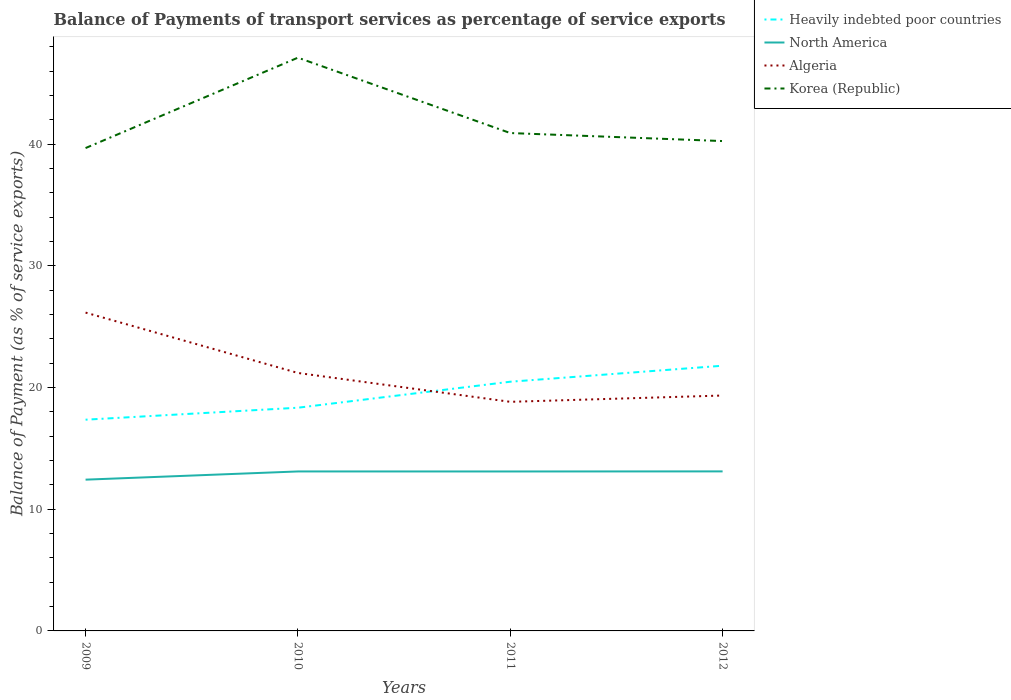How many different coloured lines are there?
Ensure brevity in your answer.  4. Does the line corresponding to Algeria intersect with the line corresponding to Korea (Republic)?
Ensure brevity in your answer.  No. Across all years, what is the maximum balance of payments of transport services in Heavily indebted poor countries?
Offer a terse response. 17.36. What is the total balance of payments of transport services in Korea (Republic) in the graph?
Make the answer very short. -7.43. What is the difference between the highest and the second highest balance of payments of transport services in Algeria?
Ensure brevity in your answer.  7.33. Is the balance of payments of transport services in Korea (Republic) strictly greater than the balance of payments of transport services in Heavily indebted poor countries over the years?
Offer a very short reply. No. How many lines are there?
Ensure brevity in your answer.  4. How many years are there in the graph?
Offer a terse response. 4. Are the values on the major ticks of Y-axis written in scientific E-notation?
Give a very brief answer. No. How are the legend labels stacked?
Your answer should be very brief. Vertical. What is the title of the graph?
Offer a very short reply. Balance of Payments of transport services as percentage of service exports. What is the label or title of the Y-axis?
Your answer should be very brief. Balance of Payment (as % of service exports). What is the Balance of Payment (as % of service exports) of Heavily indebted poor countries in 2009?
Your answer should be very brief. 17.36. What is the Balance of Payment (as % of service exports) of North America in 2009?
Provide a succinct answer. 12.43. What is the Balance of Payment (as % of service exports) in Algeria in 2009?
Make the answer very short. 26.15. What is the Balance of Payment (as % of service exports) in Korea (Republic) in 2009?
Your answer should be compact. 39.67. What is the Balance of Payment (as % of service exports) of Heavily indebted poor countries in 2010?
Offer a terse response. 18.34. What is the Balance of Payment (as % of service exports) of North America in 2010?
Your response must be concise. 13.1. What is the Balance of Payment (as % of service exports) in Algeria in 2010?
Provide a succinct answer. 21.2. What is the Balance of Payment (as % of service exports) in Korea (Republic) in 2010?
Make the answer very short. 47.1. What is the Balance of Payment (as % of service exports) of Heavily indebted poor countries in 2011?
Your response must be concise. 20.48. What is the Balance of Payment (as % of service exports) of North America in 2011?
Offer a very short reply. 13.1. What is the Balance of Payment (as % of service exports) of Algeria in 2011?
Your response must be concise. 18.82. What is the Balance of Payment (as % of service exports) in Korea (Republic) in 2011?
Offer a very short reply. 40.91. What is the Balance of Payment (as % of service exports) of Heavily indebted poor countries in 2012?
Give a very brief answer. 21.79. What is the Balance of Payment (as % of service exports) in North America in 2012?
Your response must be concise. 13.11. What is the Balance of Payment (as % of service exports) in Algeria in 2012?
Offer a very short reply. 19.34. What is the Balance of Payment (as % of service exports) in Korea (Republic) in 2012?
Your answer should be compact. 40.25. Across all years, what is the maximum Balance of Payment (as % of service exports) of Heavily indebted poor countries?
Your answer should be compact. 21.79. Across all years, what is the maximum Balance of Payment (as % of service exports) in North America?
Provide a succinct answer. 13.11. Across all years, what is the maximum Balance of Payment (as % of service exports) in Algeria?
Keep it short and to the point. 26.15. Across all years, what is the maximum Balance of Payment (as % of service exports) in Korea (Republic)?
Make the answer very short. 47.1. Across all years, what is the minimum Balance of Payment (as % of service exports) of Heavily indebted poor countries?
Offer a very short reply. 17.36. Across all years, what is the minimum Balance of Payment (as % of service exports) in North America?
Your response must be concise. 12.43. Across all years, what is the minimum Balance of Payment (as % of service exports) of Algeria?
Your response must be concise. 18.82. Across all years, what is the minimum Balance of Payment (as % of service exports) in Korea (Republic)?
Give a very brief answer. 39.67. What is the total Balance of Payment (as % of service exports) in Heavily indebted poor countries in the graph?
Your response must be concise. 77.96. What is the total Balance of Payment (as % of service exports) in North America in the graph?
Your response must be concise. 51.74. What is the total Balance of Payment (as % of service exports) of Algeria in the graph?
Offer a very short reply. 85.51. What is the total Balance of Payment (as % of service exports) of Korea (Republic) in the graph?
Provide a short and direct response. 167.93. What is the difference between the Balance of Payment (as % of service exports) in Heavily indebted poor countries in 2009 and that in 2010?
Provide a short and direct response. -0.98. What is the difference between the Balance of Payment (as % of service exports) of North America in 2009 and that in 2010?
Make the answer very short. -0.67. What is the difference between the Balance of Payment (as % of service exports) of Algeria in 2009 and that in 2010?
Give a very brief answer. 4.96. What is the difference between the Balance of Payment (as % of service exports) in Korea (Republic) in 2009 and that in 2010?
Make the answer very short. -7.43. What is the difference between the Balance of Payment (as % of service exports) of Heavily indebted poor countries in 2009 and that in 2011?
Provide a succinct answer. -3.12. What is the difference between the Balance of Payment (as % of service exports) in North America in 2009 and that in 2011?
Your answer should be very brief. -0.67. What is the difference between the Balance of Payment (as % of service exports) in Algeria in 2009 and that in 2011?
Offer a very short reply. 7.33. What is the difference between the Balance of Payment (as % of service exports) of Korea (Republic) in 2009 and that in 2011?
Offer a very short reply. -1.23. What is the difference between the Balance of Payment (as % of service exports) in Heavily indebted poor countries in 2009 and that in 2012?
Provide a short and direct response. -4.43. What is the difference between the Balance of Payment (as % of service exports) of North America in 2009 and that in 2012?
Your answer should be compact. -0.68. What is the difference between the Balance of Payment (as % of service exports) in Algeria in 2009 and that in 2012?
Keep it short and to the point. 6.81. What is the difference between the Balance of Payment (as % of service exports) in Korea (Republic) in 2009 and that in 2012?
Offer a very short reply. -0.57. What is the difference between the Balance of Payment (as % of service exports) in Heavily indebted poor countries in 2010 and that in 2011?
Keep it short and to the point. -2.14. What is the difference between the Balance of Payment (as % of service exports) of North America in 2010 and that in 2011?
Offer a very short reply. 0. What is the difference between the Balance of Payment (as % of service exports) in Algeria in 2010 and that in 2011?
Your answer should be compact. 2.37. What is the difference between the Balance of Payment (as % of service exports) of Korea (Republic) in 2010 and that in 2011?
Make the answer very short. 6.19. What is the difference between the Balance of Payment (as % of service exports) in Heavily indebted poor countries in 2010 and that in 2012?
Make the answer very short. -3.45. What is the difference between the Balance of Payment (as % of service exports) of North America in 2010 and that in 2012?
Provide a succinct answer. -0. What is the difference between the Balance of Payment (as % of service exports) in Algeria in 2010 and that in 2012?
Offer a very short reply. 1.85. What is the difference between the Balance of Payment (as % of service exports) of Korea (Republic) in 2010 and that in 2012?
Your response must be concise. 6.85. What is the difference between the Balance of Payment (as % of service exports) in Heavily indebted poor countries in 2011 and that in 2012?
Make the answer very short. -1.31. What is the difference between the Balance of Payment (as % of service exports) of North America in 2011 and that in 2012?
Your response must be concise. -0.01. What is the difference between the Balance of Payment (as % of service exports) in Algeria in 2011 and that in 2012?
Make the answer very short. -0.52. What is the difference between the Balance of Payment (as % of service exports) in Korea (Republic) in 2011 and that in 2012?
Ensure brevity in your answer.  0.66. What is the difference between the Balance of Payment (as % of service exports) of Heavily indebted poor countries in 2009 and the Balance of Payment (as % of service exports) of North America in 2010?
Give a very brief answer. 4.25. What is the difference between the Balance of Payment (as % of service exports) in Heavily indebted poor countries in 2009 and the Balance of Payment (as % of service exports) in Algeria in 2010?
Make the answer very short. -3.84. What is the difference between the Balance of Payment (as % of service exports) of Heavily indebted poor countries in 2009 and the Balance of Payment (as % of service exports) of Korea (Republic) in 2010?
Give a very brief answer. -29.75. What is the difference between the Balance of Payment (as % of service exports) in North America in 2009 and the Balance of Payment (as % of service exports) in Algeria in 2010?
Keep it short and to the point. -8.77. What is the difference between the Balance of Payment (as % of service exports) of North America in 2009 and the Balance of Payment (as % of service exports) of Korea (Republic) in 2010?
Provide a short and direct response. -34.67. What is the difference between the Balance of Payment (as % of service exports) in Algeria in 2009 and the Balance of Payment (as % of service exports) in Korea (Republic) in 2010?
Your answer should be compact. -20.95. What is the difference between the Balance of Payment (as % of service exports) of Heavily indebted poor countries in 2009 and the Balance of Payment (as % of service exports) of North America in 2011?
Keep it short and to the point. 4.25. What is the difference between the Balance of Payment (as % of service exports) of Heavily indebted poor countries in 2009 and the Balance of Payment (as % of service exports) of Algeria in 2011?
Make the answer very short. -1.47. What is the difference between the Balance of Payment (as % of service exports) of Heavily indebted poor countries in 2009 and the Balance of Payment (as % of service exports) of Korea (Republic) in 2011?
Offer a terse response. -23.55. What is the difference between the Balance of Payment (as % of service exports) in North America in 2009 and the Balance of Payment (as % of service exports) in Algeria in 2011?
Offer a very short reply. -6.39. What is the difference between the Balance of Payment (as % of service exports) of North America in 2009 and the Balance of Payment (as % of service exports) of Korea (Republic) in 2011?
Your response must be concise. -28.48. What is the difference between the Balance of Payment (as % of service exports) of Algeria in 2009 and the Balance of Payment (as % of service exports) of Korea (Republic) in 2011?
Give a very brief answer. -14.75. What is the difference between the Balance of Payment (as % of service exports) in Heavily indebted poor countries in 2009 and the Balance of Payment (as % of service exports) in North America in 2012?
Provide a short and direct response. 4.25. What is the difference between the Balance of Payment (as % of service exports) in Heavily indebted poor countries in 2009 and the Balance of Payment (as % of service exports) in Algeria in 2012?
Offer a very short reply. -1.99. What is the difference between the Balance of Payment (as % of service exports) in Heavily indebted poor countries in 2009 and the Balance of Payment (as % of service exports) in Korea (Republic) in 2012?
Give a very brief answer. -22.89. What is the difference between the Balance of Payment (as % of service exports) in North America in 2009 and the Balance of Payment (as % of service exports) in Algeria in 2012?
Your answer should be compact. -6.91. What is the difference between the Balance of Payment (as % of service exports) in North America in 2009 and the Balance of Payment (as % of service exports) in Korea (Republic) in 2012?
Offer a terse response. -27.82. What is the difference between the Balance of Payment (as % of service exports) of Algeria in 2009 and the Balance of Payment (as % of service exports) of Korea (Republic) in 2012?
Provide a succinct answer. -14.09. What is the difference between the Balance of Payment (as % of service exports) of Heavily indebted poor countries in 2010 and the Balance of Payment (as % of service exports) of North America in 2011?
Provide a short and direct response. 5.24. What is the difference between the Balance of Payment (as % of service exports) in Heavily indebted poor countries in 2010 and the Balance of Payment (as % of service exports) in Algeria in 2011?
Your answer should be compact. -0.48. What is the difference between the Balance of Payment (as % of service exports) of Heavily indebted poor countries in 2010 and the Balance of Payment (as % of service exports) of Korea (Republic) in 2011?
Ensure brevity in your answer.  -22.57. What is the difference between the Balance of Payment (as % of service exports) of North America in 2010 and the Balance of Payment (as % of service exports) of Algeria in 2011?
Your answer should be compact. -5.72. What is the difference between the Balance of Payment (as % of service exports) of North America in 2010 and the Balance of Payment (as % of service exports) of Korea (Republic) in 2011?
Give a very brief answer. -27.8. What is the difference between the Balance of Payment (as % of service exports) of Algeria in 2010 and the Balance of Payment (as % of service exports) of Korea (Republic) in 2011?
Provide a succinct answer. -19.71. What is the difference between the Balance of Payment (as % of service exports) in Heavily indebted poor countries in 2010 and the Balance of Payment (as % of service exports) in North America in 2012?
Ensure brevity in your answer.  5.23. What is the difference between the Balance of Payment (as % of service exports) of Heavily indebted poor countries in 2010 and the Balance of Payment (as % of service exports) of Algeria in 2012?
Ensure brevity in your answer.  -1. What is the difference between the Balance of Payment (as % of service exports) of Heavily indebted poor countries in 2010 and the Balance of Payment (as % of service exports) of Korea (Republic) in 2012?
Your answer should be very brief. -21.91. What is the difference between the Balance of Payment (as % of service exports) of North America in 2010 and the Balance of Payment (as % of service exports) of Algeria in 2012?
Provide a short and direct response. -6.24. What is the difference between the Balance of Payment (as % of service exports) in North America in 2010 and the Balance of Payment (as % of service exports) in Korea (Republic) in 2012?
Your answer should be very brief. -27.14. What is the difference between the Balance of Payment (as % of service exports) of Algeria in 2010 and the Balance of Payment (as % of service exports) of Korea (Republic) in 2012?
Give a very brief answer. -19.05. What is the difference between the Balance of Payment (as % of service exports) of Heavily indebted poor countries in 2011 and the Balance of Payment (as % of service exports) of North America in 2012?
Your answer should be very brief. 7.37. What is the difference between the Balance of Payment (as % of service exports) of Heavily indebted poor countries in 2011 and the Balance of Payment (as % of service exports) of Algeria in 2012?
Keep it short and to the point. 1.13. What is the difference between the Balance of Payment (as % of service exports) in Heavily indebted poor countries in 2011 and the Balance of Payment (as % of service exports) in Korea (Republic) in 2012?
Give a very brief answer. -19.77. What is the difference between the Balance of Payment (as % of service exports) in North America in 2011 and the Balance of Payment (as % of service exports) in Algeria in 2012?
Your answer should be compact. -6.24. What is the difference between the Balance of Payment (as % of service exports) of North America in 2011 and the Balance of Payment (as % of service exports) of Korea (Republic) in 2012?
Make the answer very short. -27.15. What is the difference between the Balance of Payment (as % of service exports) of Algeria in 2011 and the Balance of Payment (as % of service exports) of Korea (Republic) in 2012?
Give a very brief answer. -21.42. What is the average Balance of Payment (as % of service exports) in Heavily indebted poor countries per year?
Give a very brief answer. 19.49. What is the average Balance of Payment (as % of service exports) of North America per year?
Provide a short and direct response. 12.94. What is the average Balance of Payment (as % of service exports) of Algeria per year?
Give a very brief answer. 21.38. What is the average Balance of Payment (as % of service exports) in Korea (Republic) per year?
Provide a short and direct response. 41.98. In the year 2009, what is the difference between the Balance of Payment (as % of service exports) of Heavily indebted poor countries and Balance of Payment (as % of service exports) of North America?
Give a very brief answer. 4.93. In the year 2009, what is the difference between the Balance of Payment (as % of service exports) of Heavily indebted poor countries and Balance of Payment (as % of service exports) of Algeria?
Keep it short and to the point. -8.8. In the year 2009, what is the difference between the Balance of Payment (as % of service exports) of Heavily indebted poor countries and Balance of Payment (as % of service exports) of Korea (Republic)?
Provide a succinct answer. -22.32. In the year 2009, what is the difference between the Balance of Payment (as % of service exports) of North America and Balance of Payment (as % of service exports) of Algeria?
Provide a succinct answer. -13.73. In the year 2009, what is the difference between the Balance of Payment (as % of service exports) of North America and Balance of Payment (as % of service exports) of Korea (Republic)?
Provide a succinct answer. -27.24. In the year 2009, what is the difference between the Balance of Payment (as % of service exports) of Algeria and Balance of Payment (as % of service exports) of Korea (Republic)?
Offer a very short reply. -13.52. In the year 2010, what is the difference between the Balance of Payment (as % of service exports) in Heavily indebted poor countries and Balance of Payment (as % of service exports) in North America?
Your response must be concise. 5.24. In the year 2010, what is the difference between the Balance of Payment (as % of service exports) in Heavily indebted poor countries and Balance of Payment (as % of service exports) in Algeria?
Your answer should be compact. -2.86. In the year 2010, what is the difference between the Balance of Payment (as % of service exports) in Heavily indebted poor countries and Balance of Payment (as % of service exports) in Korea (Republic)?
Your response must be concise. -28.76. In the year 2010, what is the difference between the Balance of Payment (as % of service exports) in North America and Balance of Payment (as % of service exports) in Algeria?
Provide a succinct answer. -8.09. In the year 2010, what is the difference between the Balance of Payment (as % of service exports) in North America and Balance of Payment (as % of service exports) in Korea (Republic)?
Your answer should be very brief. -34. In the year 2010, what is the difference between the Balance of Payment (as % of service exports) in Algeria and Balance of Payment (as % of service exports) in Korea (Republic)?
Keep it short and to the point. -25.91. In the year 2011, what is the difference between the Balance of Payment (as % of service exports) of Heavily indebted poor countries and Balance of Payment (as % of service exports) of North America?
Give a very brief answer. 7.37. In the year 2011, what is the difference between the Balance of Payment (as % of service exports) of Heavily indebted poor countries and Balance of Payment (as % of service exports) of Algeria?
Your answer should be compact. 1.65. In the year 2011, what is the difference between the Balance of Payment (as % of service exports) in Heavily indebted poor countries and Balance of Payment (as % of service exports) in Korea (Republic)?
Give a very brief answer. -20.43. In the year 2011, what is the difference between the Balance of Payment (as % of service exports) of North America and Balance of Payment (as % of service exports) of Algeria?
Your response must be concise. -5.72. In the year 2011, what is the difference between the Balance of Payment (as % of service exports) of North America and Balance of Payment (as % of service exports) of Korea (Republic)?
Ensure brevity in your answer.  -27.81. In the year 2011, what is the difference between the Balance of Payment (as % of service exports) in Algeria and Balance of Payment (as % of service exports) in Korea (Republic)?
Your answer should be compact. -22.08. In the year 2012, what is the difference between the Balance of Payment (as % of service exports) in Heavily indebted poor countries and Balance of Payment (as % of service exports) in North America?
Ensure brevity in your answer.  8.68. In the year 2012, what is the difference between the Balance of Payment (as % of service exports) of Heavily indebted poor countries and Balance of Payment (as % of service exports) of Algeria?
Make the answer very short. 2.45. In the year 2012, what is the difference between the Balance of Payment (as % of service exports) of Heavily indebted poor countries and Balance of Payment (as % of service exports) of Korea (Republic)?
Keep it short and to the point. -18.46. In the year 2012, what is the difference between the Balance of Payment (as % of service exports) in North America and Balance of Payment (as % of service exports) in Algeria?
Give a very brief answer. -6.23. In the year 2012, what is the difference between the Balance of Payment (as % of service exports) of North America and Balance of Payment (as % of service exports) of Korea (Republic)?
Keep it short and to the point. -27.14. In the year 2012, what is the difference between the Balance of Payment (as % of service exports) in Algeria and Balance of Payment (as % of service exports) in Korea (Republic)?
Ensure brevity in your answer.  -20.91. What is the ratio of the Balance of Payment (as % of service exports) in Heavily indebted poor countries in 2009 to that in 2010?
Your answer should be compact. 0.95. What is the ratio of the Balance of Payment (as % of service exports) of North America in 2009 to that in 2010?
Your answer should be compact. 0.95. What is the ratio of the Balance of Payment (as % of service exports) in Algeria in 2009 to that in 2010?
Offer a very short reply. 1.23. What is the ratio of the Balance of Payment (as % of service exports) in Korea (Republic) in 2009 to that in 2010?
Keep it short and to the point. 0.84. What is the ratio of the Balance of Payment (as % of service exports) of Heavily indebted poor countries in 2009 to that in 2011?
Your response must be concise. 0.85. What is the ratio of the Balance of Payment (as % of service exports) of North America in 2009 to that in 2011?
Your response must be concise. 0.95. What is the ratio of the Balance of Payment (as % of service exports) in Algeria in 2009 to that in 2011?
Give a very brief answer. 1.39. What is the ratio of the Balance of Payment (as % of service exports) of Korea (Republic) in 2009 to that in 2011?
Provide a succinct answer. 0.97. What is the ratio of the Balance of Payment (as % of service exports) of Heavily indebted poor countries in 2009 to that in 2012?
Keep it short and to the point. 0.8. What is the ratio of the Balance of Payment (as % of service exports) in North America in 2009 to that in 2012?
Provide a succinct answer. 0.95. What is the ratio of the Balance of Payment (as % of service exports) of Algeria in 2009 to that in 2012?
Offer a very short reply. 1.35. What is the ratio of the Balance of Payment (as % of service exports) in Korea (Republic) in 2009 to that in 2012?
Your answer should be compact. 0.99. What is the ratio of the Balance of Payment (as % of service exports) of Heavily indebted poor countries in 2010 to that in 2011?
Ensure brevity in your answer.  0.9. What is the ratio of the Balance of Payment (as % of service exports) in North America in 2010 to that in 2011?
Provide a short and direct response. 1. What is the ratio of the Balance of Payment (as % of service exports) in Algeria in 2010 to that in 2011?
Your answer should be compact. 1.13. What is the ratio of the Balance of Payment (as % of service exports) of Korea (Republic) in 2010 to that in 2011?
Offer a very short reply. 1.15. What is the ratio of the Balance of Payment (as % of service exports) of Heavily indebted poor countries in 2010 to that in 2012?
Offer a very short reply. 0.84. What is the ratio of the Balance of Payment (as % of service exports) of North America in 2010 to that in 2012?
Provide a short and direct response. 1. What is the ratio of the Balance of Payment (as % of service exports) in Algeria in 2010 to that in 2012?
Offer a terse response. 1.1. What is the ratio of the Balance of Payment (as % of service exports) in Korea (Republic) in 2010 to that in 2012?
Keep it short and to the point. 1.17. What is the ratio of the Balance of Payment (as % of service exports) of Heavily indebted poor countries in 2011 to that in 2012?
Your answer should be compact. 0.94. What is the ratio of the Balance of Payment (as % of service exports) in North America in 2011 to that in 2012?
Your answer should be very brief. 1. What is the ratio of the Balance of Payment (as % of service exports) in Algeria in 2011 to that in 2012?
Keep it short and to the point. 0.97. What is the ratio of the Balance of Payment (as % of service exports) of Korea (Republic) in 2011 to that in 2012?
Give a very brief answer. 1.02. What is the difference between the highest and the second highest Balance of Payment (as % of service exports) in Heavily indebted poor countries?
Ensure brevity in your answer.  1.31. What is the difference between the highest and the second highest Balance of Payment (as % of service exports) in North America?
Your answer should be very brief. 0. What is the difference between the highest and the second highest Balance of Payment (as % of service exports) in Algeria?
Provide a short and direct response. 4.96. What is the difference between the highest and the second highest Balance of Payment (as % of service exports) in Korea (Republic)?
Offer a terse response. 6.19. What is the difference between the highest and the lowest Balance of Payment (as % of service exports) in Heavily indebted poor countries?
Make the answer very short. 4.43. What is the difference between the highest and the lowest Balance of Payment (as % of service exports) in North America?
Offer a terse response. 0.68. What is the difference between the highest and the lowest Balance of Payment (as % of service exports) in Algeria?
Give a very brief answer. 7.33. What is the difference between the highest and the lowest Balance of Payment (as % of service exports) of Korea (Republic)?
Your response must be concise. 7.43. 